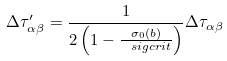<formula> <loc_0><loc_0><loc_500><loc_500>\Delta \tau ^ { \prime } _ { \alpha \beta } = \frac { 1 } { 2 \left ( 1 - \frac { \sigma _ { 0 } ( b ) } { \ s i g c r i t } \right ) } \Delta \tau _ { \alpha \beta }</formula> 